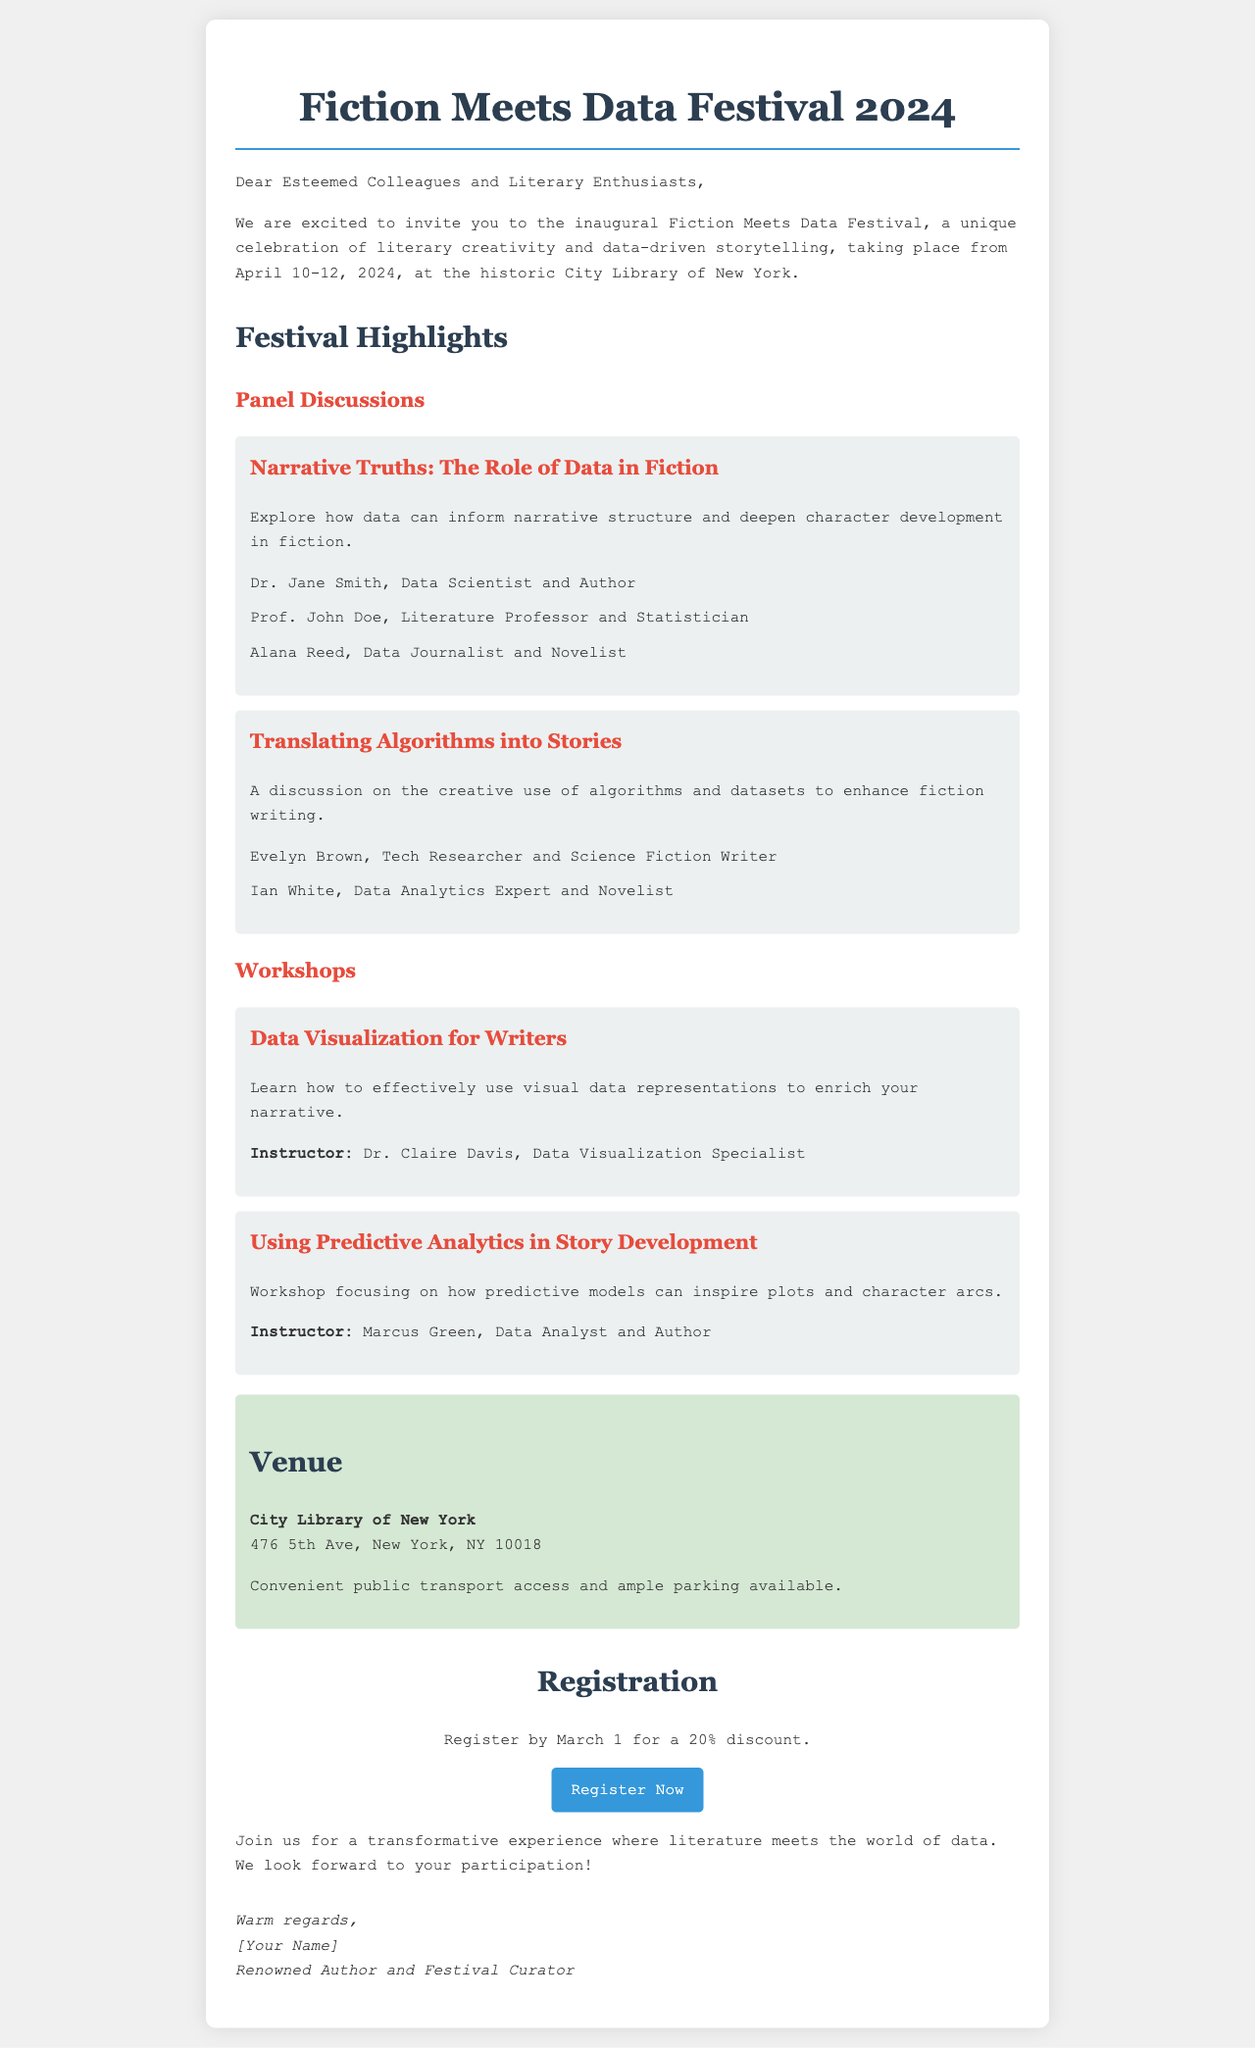What are the festival dates? The festival dates are specified in the invitation as taking place from April 10-12, 2024.
Answer: April 10-12, 2024 Where is the festival venue? The venue for the festival is mentioned in the document as the City Library of New York.
Answer: City Library of New York Who is the instructor for the "Data Visualization for Writers" workshop? The instructor's name for this workshop is provided in the document and is Dr. Claire Davis.
Answer: Dr. Claire Davis What discount is available for early registration? The discount offered for registering by a certain date is stated in the invitation as 20%.
Answer: 20% What is the theme of the first panel discussion? The theme for the first panel discussion is introduced in the document as “Narrative Truths: The Role of Data in Fiction.”
Answer: Narrative Truths: The Role of Data in Fiction How many panel discussions are featured in the festival? The document lists two specific panel discussions under the highlights section.
Answer: Two What is the registration deadline for the discount? The registration deadline for the discount is specified as March 1.
Answer: March 1 What is the focus of the second workshop? The focus of the second workshop is detailed in the document as using predictive models to inspire plots and character arcs.
Answer: Using predictive models to inspire plots and character arcs 